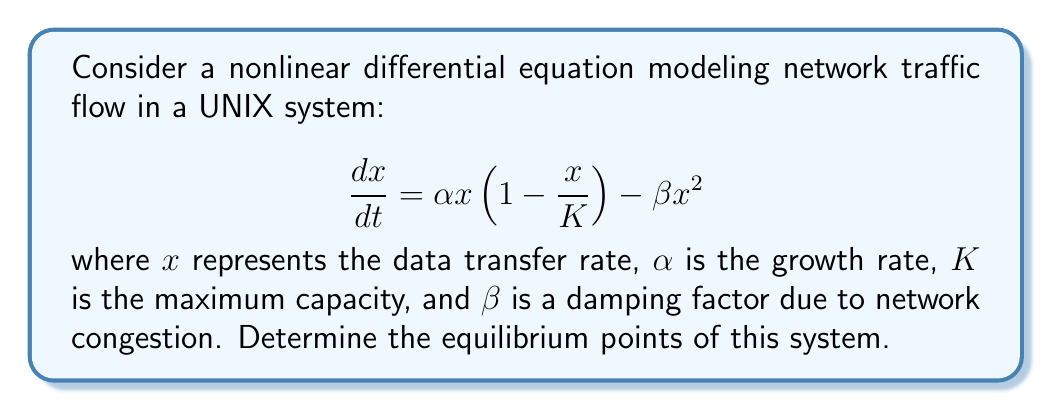What is the answer to this math problem? To find the equilibrium points, we set $\frac{dx}{dt} = 0$ and solve for $x$:

1) Set the equation to zero:
   $$\alpha x(1 - \frac{x}{K}) - \beta x^2 = 0$$

2) Factor out $x$:
   $$x(\alpha(1 - \frac{x}{K}) - \beta x) = 0$$

3) This equation is satisfied when either $x = 0$ or the term in parentheses is zero. Let's solve the latter:
   $$\alpha(1 - \frac{x}{K}) - \beta x = 0$$

4) Multiply both sides by $K$:
   $$\alpha K - \alpha x - \beta K x = 0$$

5) Rearrange terms:
   $$\alpha K = x(\alpha + \beta K)$$

6) Solve for $x$:
   $$x = \frac{\alpha K}{\alpha + \beta K}$$

Therefore, we have two equilibrium points: $x = 0$ and $x = \frac{\alpha K}{\alpha + \beta K}$.

The first point ($x = 0$) represents no data transfer, while the second point represents a non-zero steady-state transfer rate that balances growth and congestion effects.
Answer: $x = 0$ and $x = \frac{\alpha K}{\alpha + \beta K}$ 